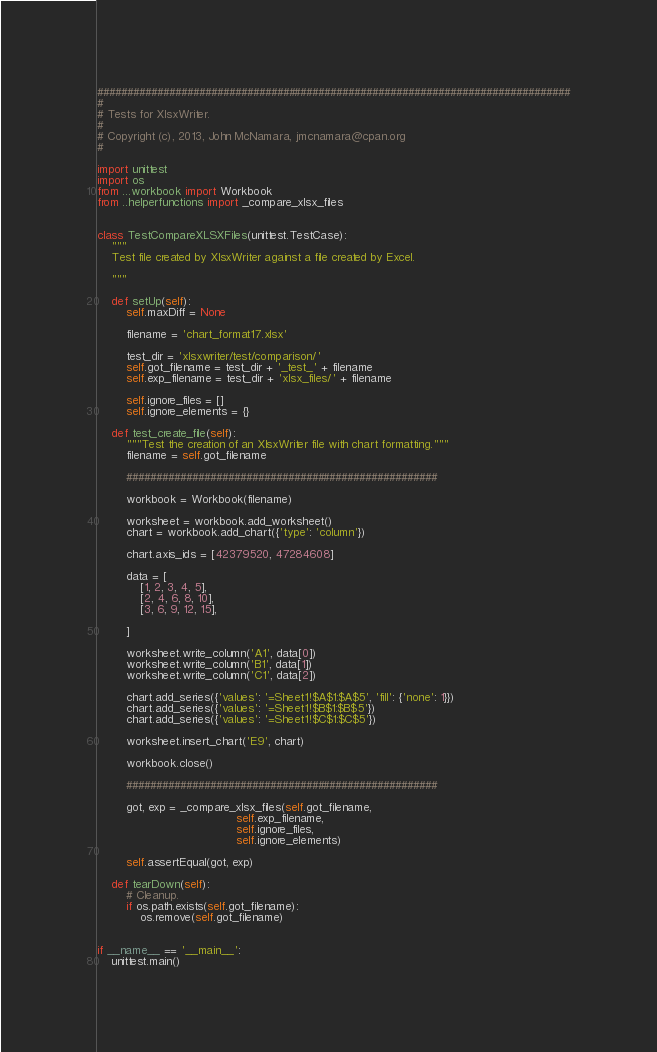<code> <loc_0><loc_0><loc_500><loc_500><_Python_>###############################################################################
#
# Tests for XlsxWriter.
#
# Copyright (c), 2013, John McNamara, jmcnamara@cpan.org
#

import unittest
import os
from ...workbook import Workbook
from ..helperfunctions import _compare_xlsx_files


class TestCompareXLSXFiles(unittest.TestCase):
    """
    Test file created by XlsxWriter against a file created by Excel.

    """

    def setUp(self):
        self.maxDiff = None

        filename = 'chart_format17.xlsx'

        test_dir = 'xlsxwriter/test/comparison/'
        self.got_filename = test_dir + '_test_' + filename
        self.exp_filename = test_dir + 'xlsx_files/' + filename

        self.ignore_files = []
        self.ignore_elements = {}

    def test_create_file(self):
        """Test the creation of an XlsxWriter file with chart formatting."""
        filename = self.got_filename

        ####################################################

        workbook = Workbook(filename)

        worksheet = workbook.add_worksheet()
        chart = workbook.add_chart({'type': 'column'})

        chart.axis_ids = [42379520, 47284608]

        data = [
            [1, 2, 3, 4, 5],
            [2, 4, 6, 8, 10],
            [3, 6, 9, 12, 15],

        ]

        worksheet.write_column('A1', data[0])
        worksheet.write_column('B1', data[1])
        worksheet.write_column('C1', data[2])

        chart.add_series({'values': '=Sheet1!$A$1:$A$5', 'fill': {'none': 1}})
        chart.add_series({'values': '=Sheet1!$B$1:$B$5'})
        chart.add_series({'values': '=Sheet1!$C$1:$C$5'})

        worksheet.insert_chart('E9', chart)

        workbook.close()

        ####################################################

        got, exp = _compare_xlsx_files(self.got_filename,
                                       self.exp_filename,
                                       self.ignore_files,
                                       self.ignore_elements)

        self.assertEqual(got, exp)

    def tearDown(self):
        # Cleanup.
        if os.path.exists(self.got_filename):
            os.remove(self.got_filename)


if __name__ == '__main__':
    unittest.main()
</code> 